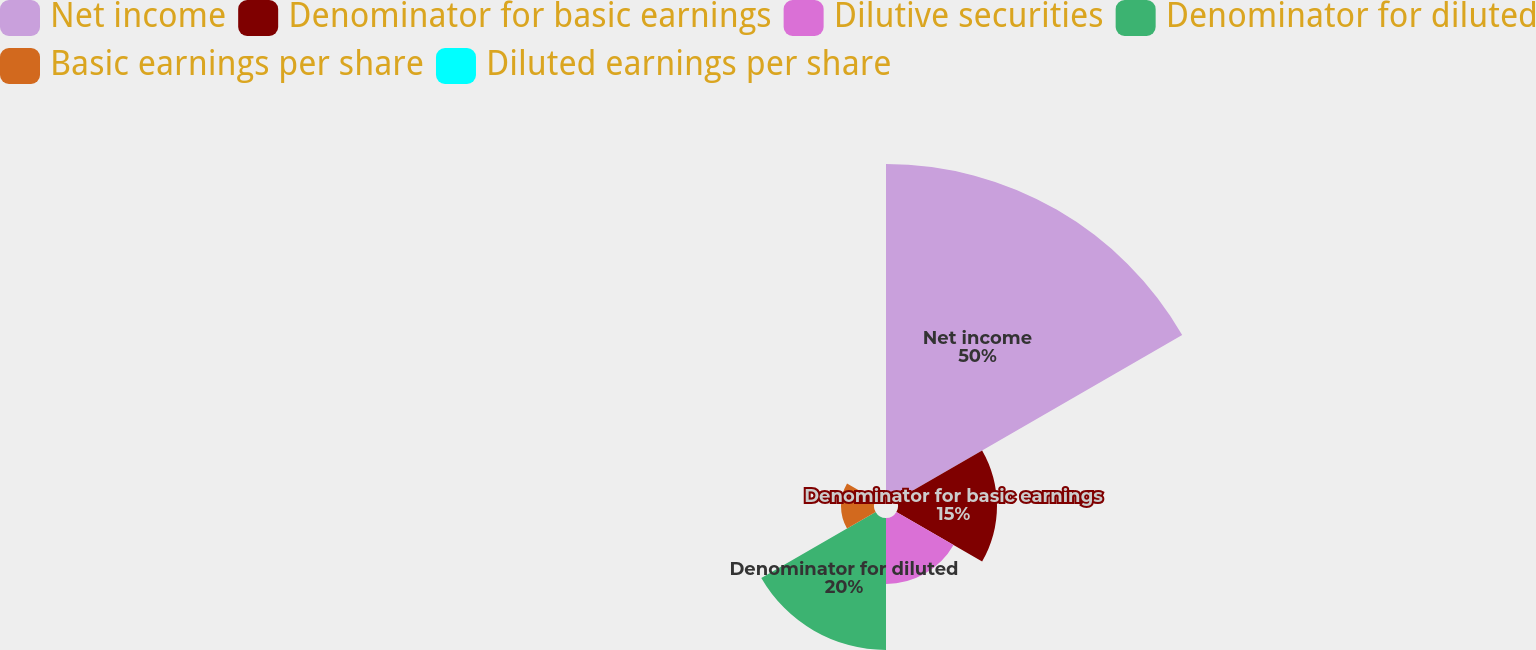<chart> <loc_0><loc_0><loc_500><loc_500><pie_chart><fcel>Net income<fcel>Denominator for basic earnings<fcel>Dilutive securities<fcel>Denominator for diluted<fcel>Basic earnings per share<fcel>Diluted earnings per share<nl><fcel>50.0%<fcel>15.0%<fcel>10.0%<fcel>20.0%<fcel>5.0%<fcel>0.0%<nl></chart> 